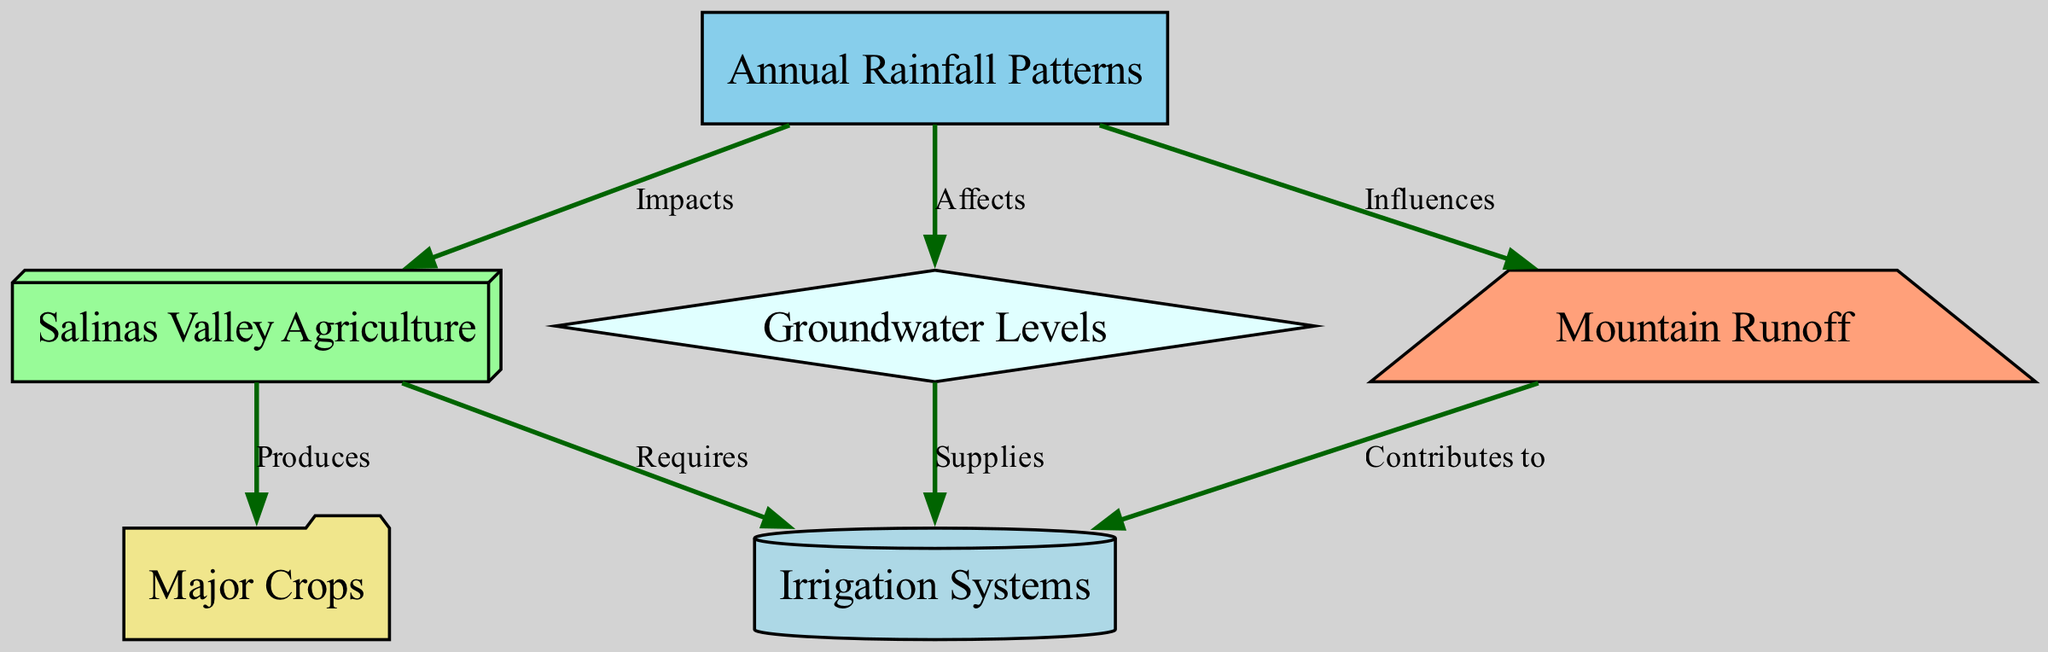What is the label of the node representing the flow of water from mountains? The node that describes the flow of water from mountains is labeled "Mountain Runoff." This can be identified directly from the nodes listed in the diagram.
Answer: Mountain Runoff How many nodes are present in the diagram? To determine the number of nodes, we count each distinct entity represented: "Annual Rainfall Patterns," "Salinas Valley Agriculture," "Major Crops," "Irrigation Systems," "Groundwater Levels," and "Mountain Runoff." There are six nodes total.
Answer: 6 What relationship exists between Annual Rainfall Patterns and Salinas Valley Agriculture? The relationship indicated is "Impacts," which shows that annual rainfall patterns directly affect agricultural practices in the Salinas Valley. This connection is denoted by an edge in the diagram between these two nodes.
Answer: Impacts Which node is said to supply irrigation systems? The node labeled "Groundwater Levels" has a directional edge indicating that it supplies irrigation systems. By following the edge from the groundwater node, we see this relationship explicitly stated.
Answer: Groundwater Levels How do Mountain Runoff and Groundwater Levels interact in the diagram? Mountain Runoff is linked to Groundwater Levels by an influence relationship. Since runoff affects groundwater levels, these two nodes have a direct connection that reflects their relationship in the context of the diagram.
Answer: Influences What are the major crops produced in Salinas Valley Agriculture? The major crops are illustrated under the node "Major Crops," which relates directly to the agriculture node with a "Produces" relationship. This shows that various crops are a product of agricultural efforts in the valley.
Answer: Major Crops What role does Annual Rainfall Patterns have on Groundwater Levels? The diagram indicates that annual rainfall patterns "Affects" groundwater levels. This shows that the volume of rainfall each year has a direct impact on the levels of groundwater available in the area.
Answer: Affects Which system contributes to irrigation, according to the diagram? "Mountain Runoff" is the system that contributes to irrigation, as shown by the directed edge labeled "Contributes to" that connects Mountain Runoff to the Irrigation Systems node.
Answer: Mountain Runoff 